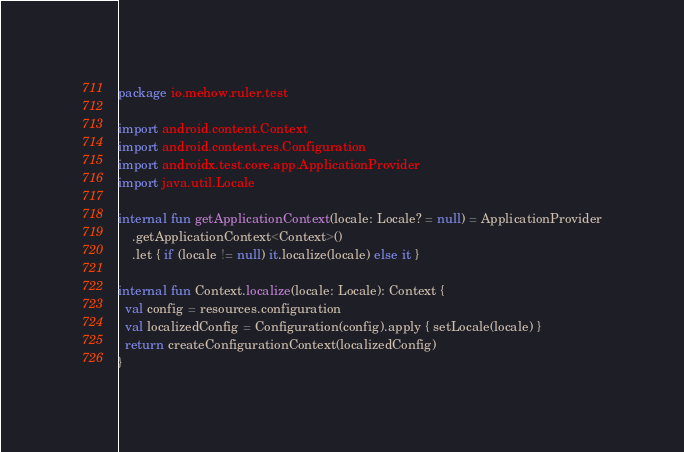<code> <loc_0><loc_0><loc_500><loc_500><_Kotlin_>package io.mehow.ruler.test

import android.content.Context
import android.content.res.Configuration
import androidx.test.core.app.ApplicationProvider
import java.util.Locale

internal fun getApplicationContext(locale: Locale? = null) = ApplicationProvider
    .getApplicationContext<Context>()
    .let { if (locale != null) it.localize(locale) else it }

internal fun Context.localize(locale: Locale): Context {
  val config = resources.configuration
  val localizedConfig = Configuration(config).apply { setLocale(locale) }
  return createConfigurationContext(localizedConfig)
}
</code> 